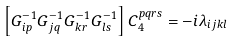<formula> <loc_0><loc_0><loc_500><loc_500>\left [ G _ { i p } ^ { - 1 } G _ { j q } ^ { - 1 } G _ { k r } ^ { - 1 } G _ { l s } ^ { - 1 } \right ] C _ { 4 } ^ { p q r s } = - i \lambda _ { i j k l }</formula> 